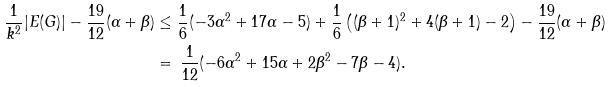Convert formula to latex. <formula><loc_0><loc_0><loc_500><loc_500>\frac { 1 } { k ^ { 2 } } | E ( G ) | - \frac { 1 9 } { 1 2 } ( \alpha + \beta ) & \leq \frac { 1 } { 6 } ( - 3 \alpha ^ { 2 } + 1 7 \alpha - 5 ) + \frac { 1 } { 6 } \left ( ( \beta + 1 ) ^ { 2 } + 4 ( \beta + 1 ) - 2 \right ) - \frac { 1 9 } { 1 2 } ( \alpha + \beta ) \, \\ & = \, \frac { 1 } { 1 2 } ( - 6 \alpha ^ { 2 } + 1 5 \alpha + 2 \beta ^ { 2 } - 7 \beta - 4 ) .</formula> 